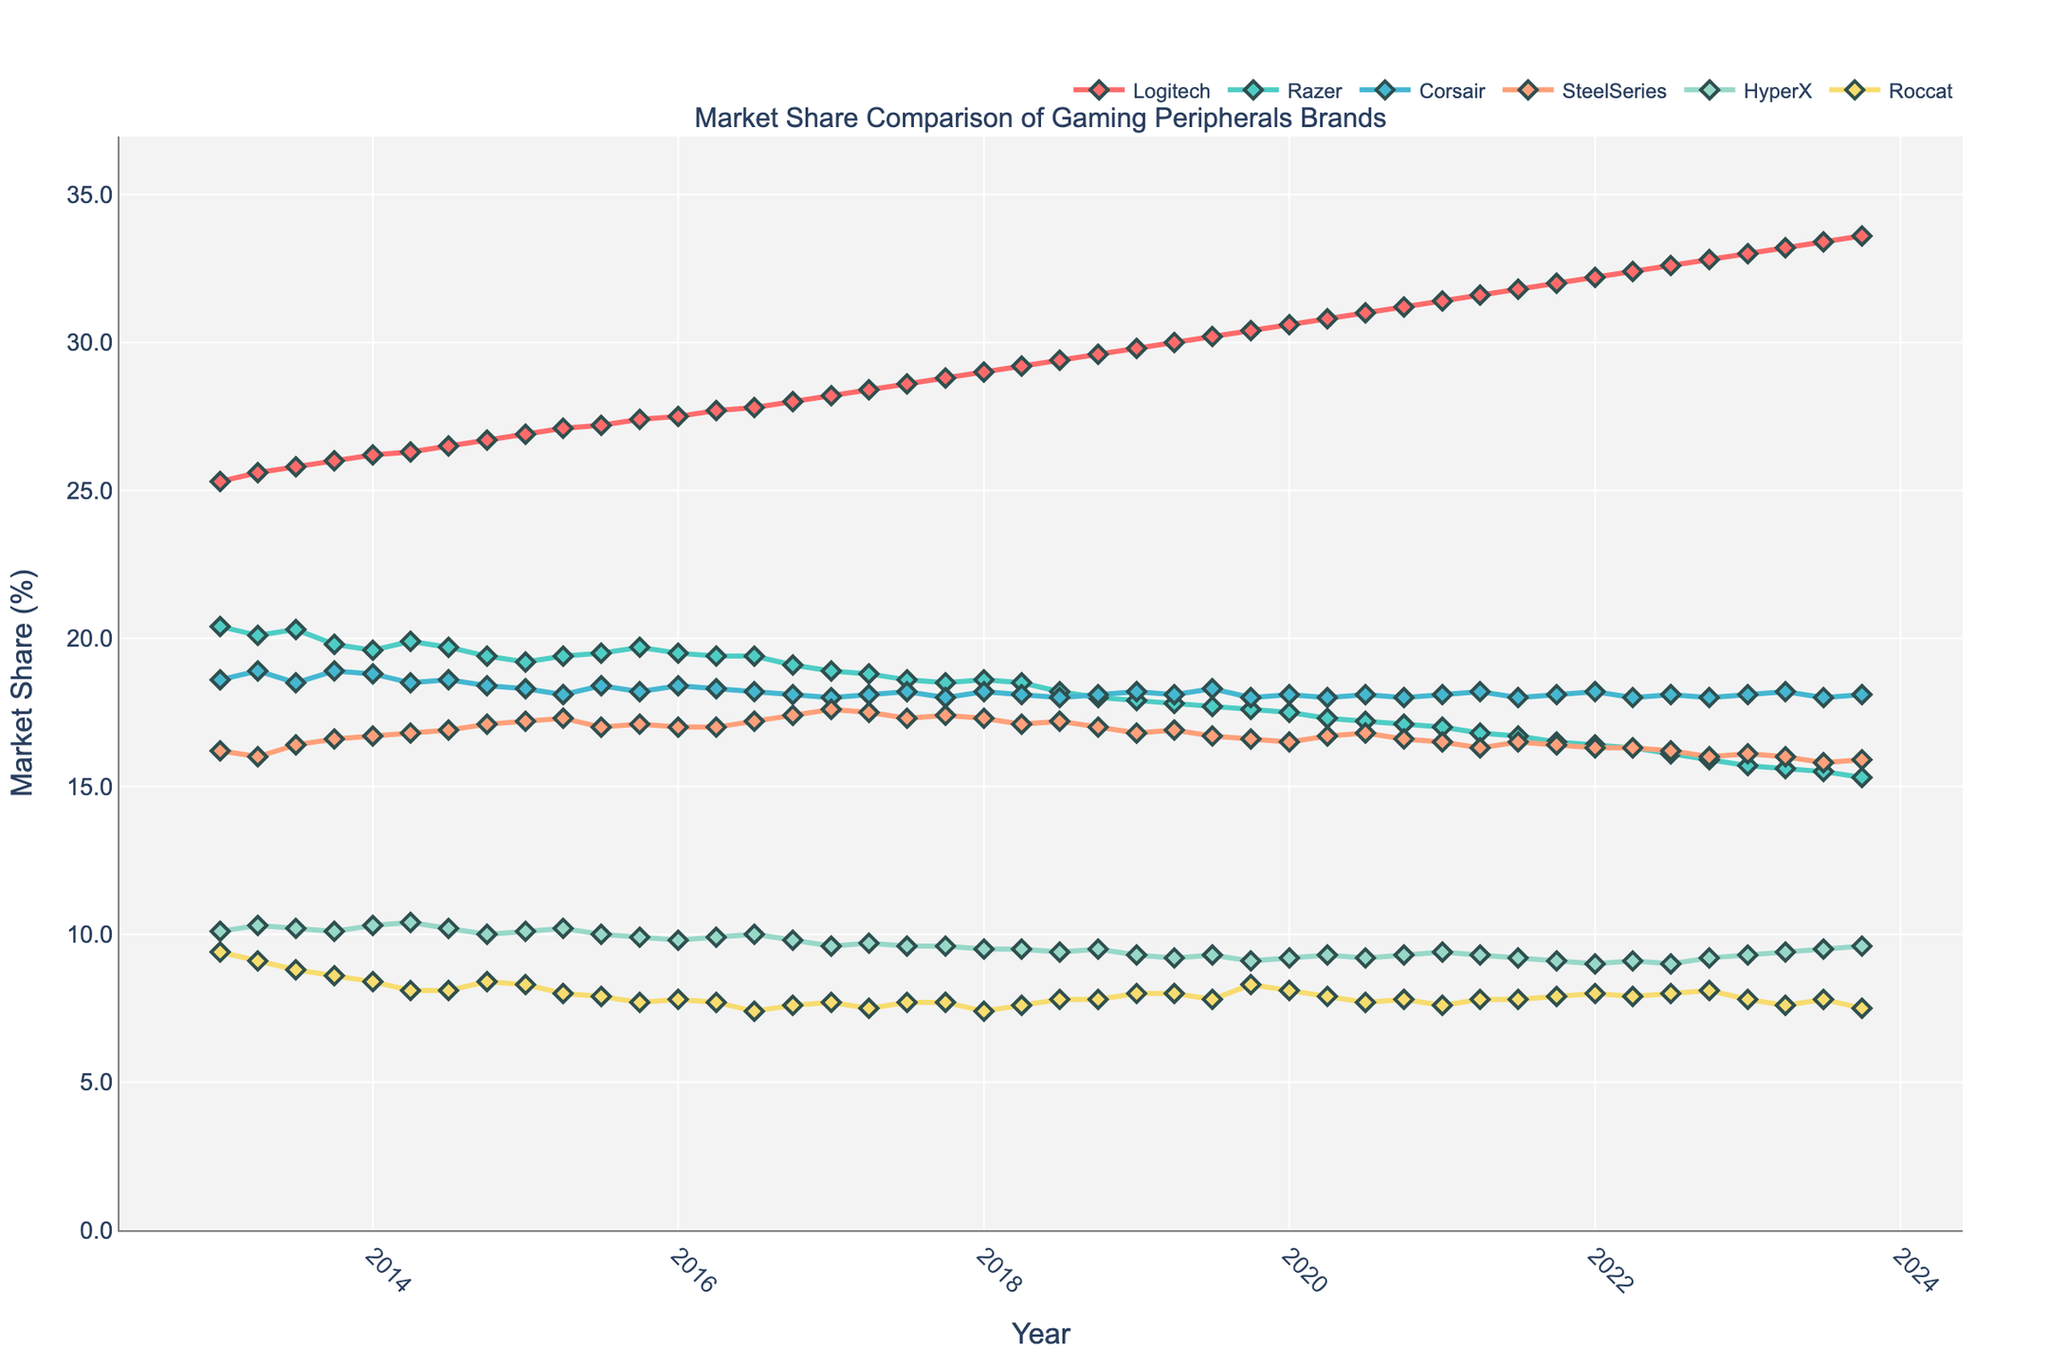What is the overall trend for Logitech’s market share from 2013 to 2023? The market share of Logitech starts at around 25% in early 2013 and steadily increases over the years, reaching approximately 33.6% by late 2023. This indicates a consistent growth over the decade.
Answer: Consistent growth Which brand experienced the most significant decline in market share over the decade? By looking at the plot, Razer's market share declines from about 20.4% in 2013 to around 15.3% in 2023. This is the largest drop among the brands shown.
Answer: Razer Comparing Corsair and HyperX, which brand had a more stable market share throughout the years? Corsair’s market share remains between roughly 18% and 18.9% throughout the years, showing minimal fluctuations. In contrast, HyperX shows variations between approximately 9% and 10.4%, indicating less stability than Corsair.
Answer: Corsair In which quarter did SteelSeries achieve its peak market share, and what was the percentage? SteelSeries reached its peak market share in the last quarter of 2017 (2017-Q4) at approximately 17.6%.
Answer: 2017-Q4, 17.6% How did Roccat’s market share change from 2013-Q1 to 2023-Q4? Roccat’s market share starts at around 9.4% in 2013-Q1, fluctuates slightly, and drops to approximately 7.5% by 2023-Q4.
Answer: Decreased from 9.4% to 7.5% During which period was HyperX's market share the lowest, and what was the percentage? HyperX's market share is at its lowest between 2013-Q1 and 2014-Q4, with the minimum being around 9.0% occurring in several quarters such as 2014-Q4 and 2022-Q3.
Answer: 2014-Q4, 9.0% Between 2018 and 2023, which brand showed the largest increase in market share? Logitech's market share increased continually from about 29% in 2018 to approximately 33.6% in 2023, showing the largest increase among the brands.
Answer: Logitech What is the average market share for Corsair over the entire period depicted in the plot? To find Corsair’s average market share, sum up the quarterly market share percentages and divide by the number of quarters. Corsair’s market share remains relatively stable, averaging roughly around 18.2%.
Answer: Approximately 18.2% How does the market share of HyperX in 2023-Q4 compare to its share in 2013-Q1? HyperX starts at around 10.1% in 2013-Q1 and ends at approximately 9.6% in 2023-Q4. This indicates a slight decrease in market share over the period.
Answer: Slight decrease from 10.1% to 9.6% Which brand had the least variation in market share over the decade and how can you tell? Corsair had the least variation, maintaining a relatively stable range between approximately 18% and 18.9%, with minimal fluctuations compared to other brands in the plot.
Answer: Corsair, stable range 